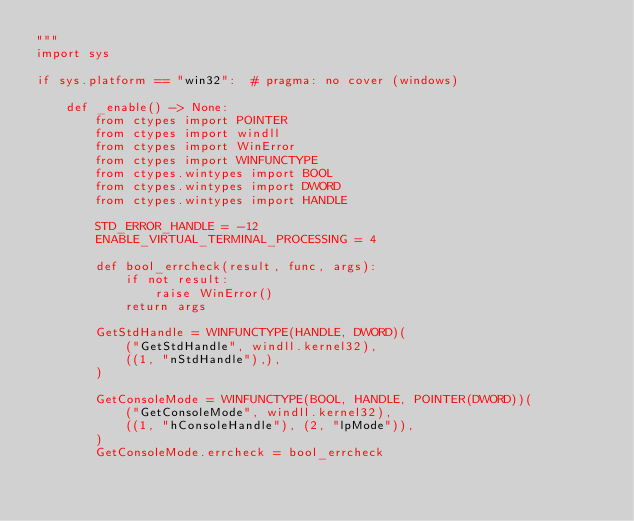<code> <loc_0><loc_0><loc_500><loc_500><_Python_>"""
import sys

if sys.platform == "win32":  # pragma: no cover (windows)

    def _enable() -> None:
        from ctypes import POINTER
        from ctypes import windll
        from ctypes import WinError
        from ctypes import WINFUNCTYPE
        from ctypes.wintypes import BOOL
        from ctypes.wintypes import DWORD
        from ctypes.wintypes import HANDLE

        STD_ERROR_HANDLE = -12
        ENABLE_VIRTUAL_TERMINAL_PROCESSING = 4

        def bool_errcheck(result, func, args):
            if not result:
                raise WinError()
            return args

        GetStdHandle = WINFUNCTYPE(HANDLE, DWORD)(
            ("GetStdHandle", windll.kernel32),
            ((1, "nStdHandle"),),
        )

        GetConsoleMode = WINFUNCTYPE(BOOL, HANDLE, POINTER(DWORD))(
            ("GetConsoleMode", windll.kernel32),
            ((1, "hConsoleHandle"), (2, "lpMode")),
        )
        GetConsoleMode.errcheck = bool_errcheck
</code> 